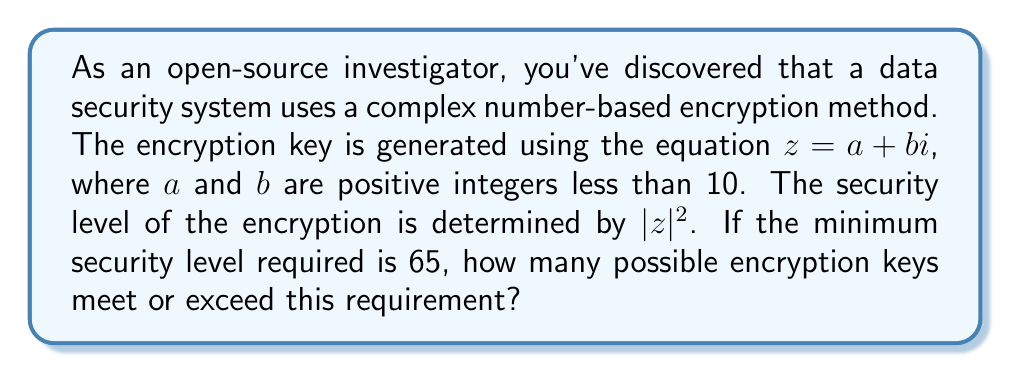Help me with this question. To solve this problem, we need to follow these steps:

1) The magnitude of a complex number $z = a + bi$ is given by $|z| = \sqrt{a^2 + b^2}$.

2) The security level is determined by $|z|^2$, which is equal to $a^2 + b^2$.

3) We need to find all pairs of positive integers $(a,b)$ where $1 \leq a,b \leq 9$ that satisfy:

   $a^2 + b^2 \geq 65$

4) Let's list out all possible pairs:

   $(8,1), (1,8)$
   $(8,2), (2,8)$
   $(8,3), (3,8)$
   $(8,4), (4,8)$
   $(8,5), (5,8)$
   $(8,6), (6,8)$
   $(8,7), (7,8)$
   $(8,8)$
   $(8,9), (9,8)$
   $(7,6), (6,7)$
   $(7,7)$
   $(7,8), (8,7)$
   $(7,9), (9,7)$
   $(6,7), (7,6)$
   $(6,8), (8,6)$
   $(6,9), (9,6)$
   $(5,8), (8,5)$
   $(5,9), (9,5)$
   $(4,9), (9,4)$
   $(3,9), (9,3)$
   $(2,9), (9,2)$
   $(1,9), (9,1)$

5) Counting these pairs, we find that there are 41 possible encryption keys that meet or exceed the required security level.
Answer: 41 possible encryption keys 